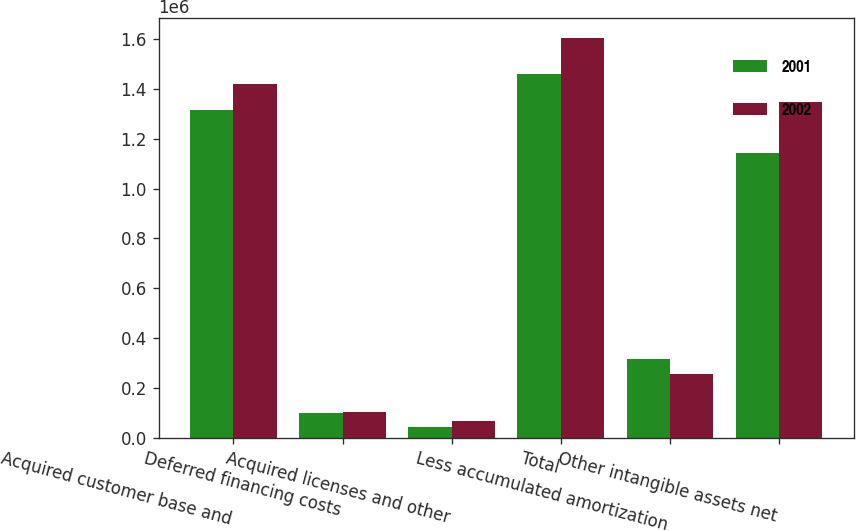Convert chart. <chart><loc_0><loc_0><loc_500><loc_500><stacked_bar_chart><ecel><fcel>Acquired customer base and<fcel>Deferred financing costs<fcel>Acquired licenses and other<fcel>Total<fcel>Less accumulated amortization<fcel>Other intangible assets net<nl><fcel>2001<fcel>1.31606e+06<fcel>100408<fcel>43054<fcel>1.45952e+06<fcel>317010<fcel>1.14251e+06<nl><fcel>2002<fcel>1.42101e+06<fcel>104957<fcel>65914<fcel>1.60494e+06<fcel>257417<fcel>1.34752e+06<nl></chart> 